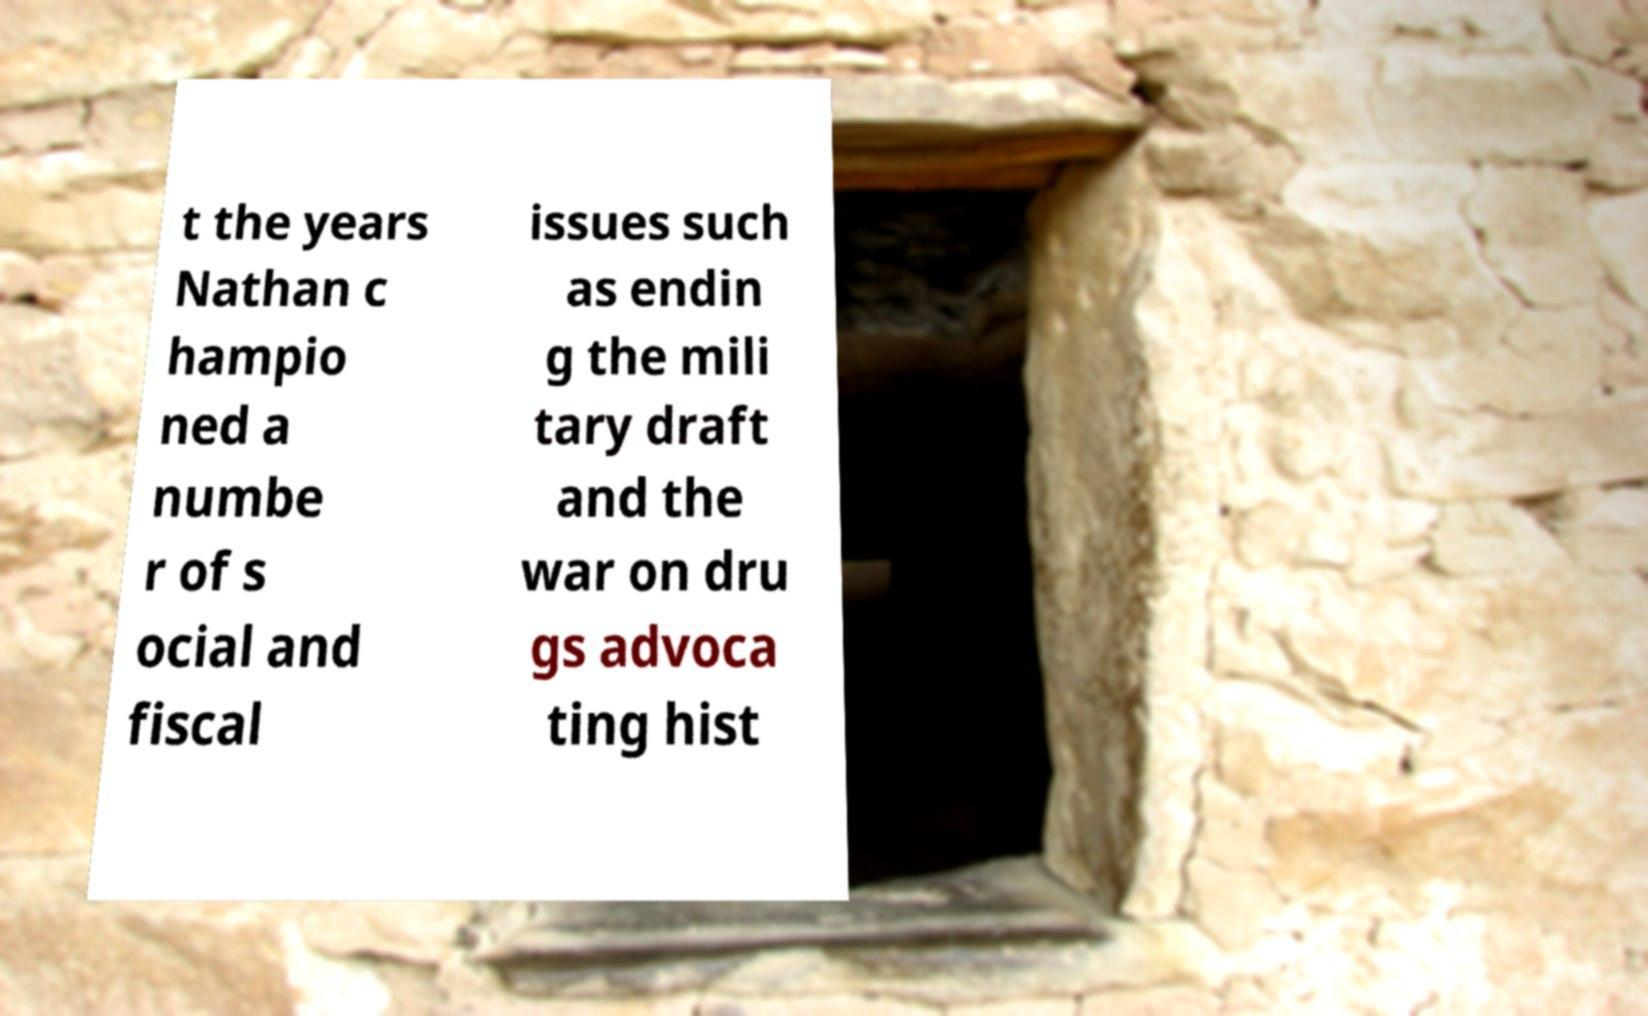What messages or text are displayed in this image? I need them in a readable, typed format. t the years Nathan c hampio ned a numbe r of s ocial and fiscal issues such as endin g the mili tary draft and the war on dru gs advoca ting hist 